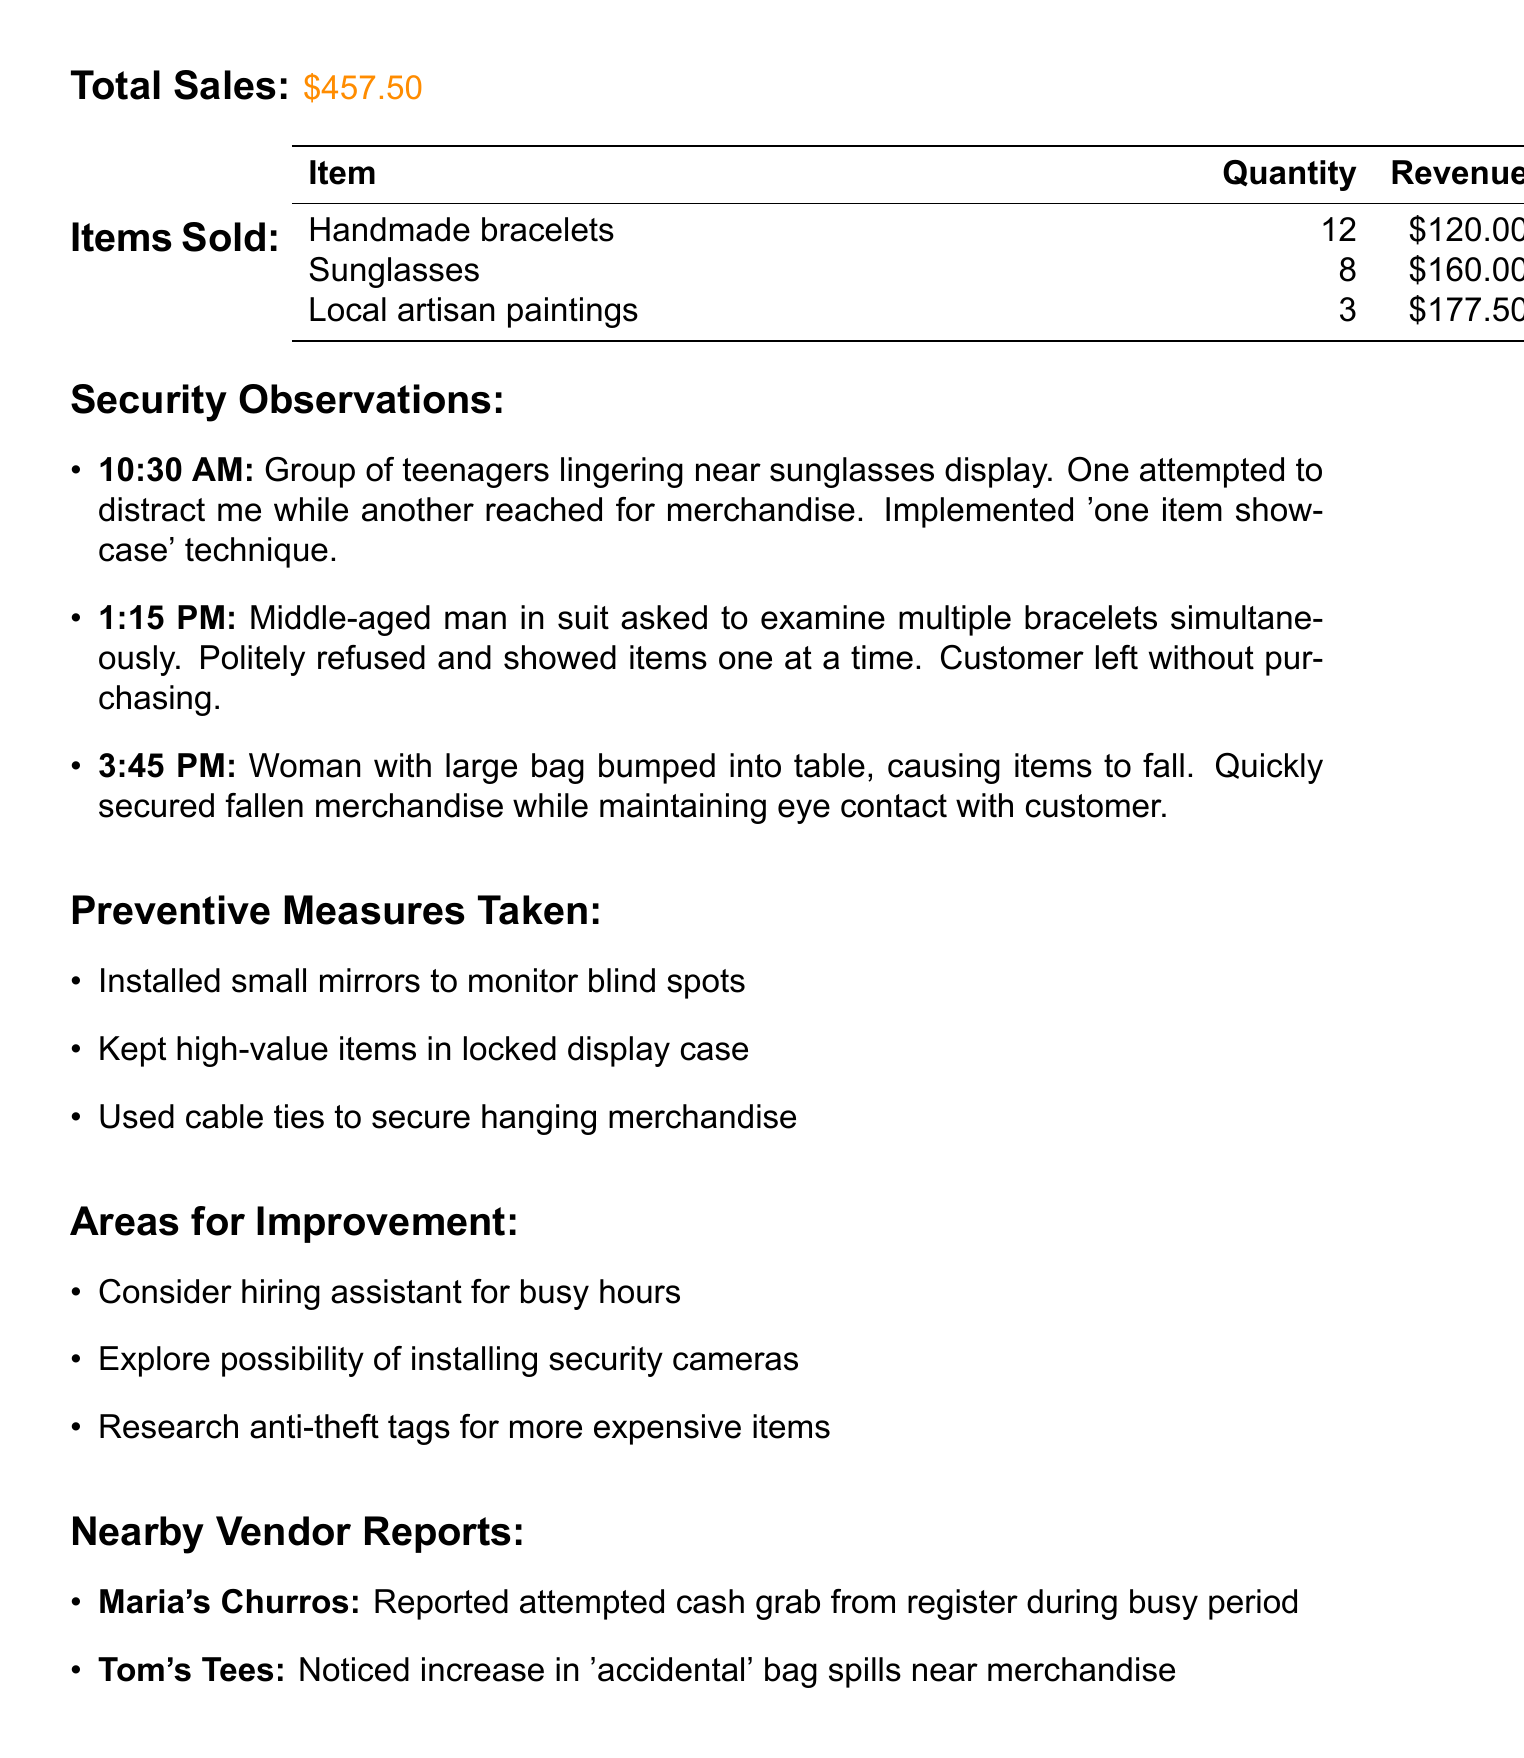What is the total sales amount? The total sales amount is stated directly in the document as the overall revenue generated from sales.
Answer: $457.50 How many handmade bracelets were sold? The itemized list of sales includes a specific quantity sold for each item, including handmade bracelets.
Answer: 12 What time was the first security observation noted? The security observations are listed chronologically, with the first one providing a time reference.
Answer: 10:30 AM Who is the police officer mentioned in the report? The police presence section provides the name of the officer ensuring security at the market.
Answer: Officer Johnson What incident was reported by Maria's Churros? The nearby vendor reports include specific incidents that vendors experienced related to security concerns.
Answer: Attempted cash grab from register How did customers feel about the visible security measures? Customer feedback includes opinions gathered which reflect the response to security measures in place.
Answer: Felt safe shopping What was a preventive measure taken to enhance security? The preventive measures section highlights actions taken to improve the vendor's security.
Answer: Installed small mirrors to monitor blind spots What area for improvement is mentioned regarding staffing? Areas for improvement suggest potential changes to enhance security and operations in the market.
Answer: Consider hiring assistant for busy hours 